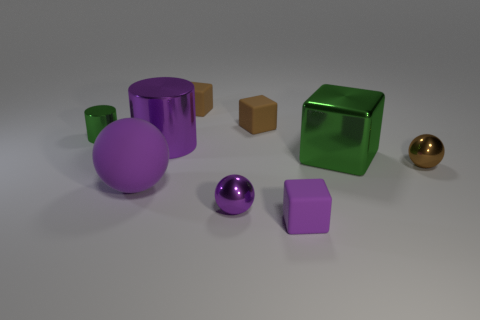How many purple things are large spheres or matte cubes?
Keep it short and to the point. 2. What number of green metallic cylinders are to the right of the tiny purple matte thing on the right side of the tiny cylinder?
Provide a succinct answer. 0. Are there more purple spheres that are behind the big cylinder than small spheres that are in front of the small brown metallic thing?
Ensure brevity in your answer.  No. What is the green block made of?
Your answer should be very brief. Metal. Are there any green metallic cylinders of the same size as the purple cylinder?
Provide a short and direct response. No. There is a cylinder that is the same size as the brown sphere; what is its material?
Your answer should be very brief. Metal. How many metallic cylinders are there?
Offer a terse response. 2. How big is the metallic cylinder behind the large shiny cylinder?
Ensure brevity in your answer.  Small. Are there the same number of balls that are in front of the big green thing and purple matte things?
Your answer should be compact. No. Are there any brown matte things of the same shape as the small green metallic thing?
Make the answer very short. No. 